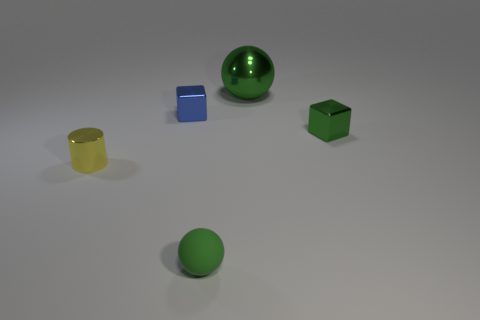Is there anything else that has the same size as the green metal sphere?
Provide a succinct answer. No. Is the number of tiny green rubber balls behind the blue cube less than the number of large objects?
Your answer should be compact. Yes. Do the large metal object and the tiny metal cylinder have the same color?
Offer a terse response. No. What size is the metallic object that is the same shape as the green matte object?
Offer a very short reply. Large. What number of other things are the same material as the blue object?
Ensure brevity in your answer.  3. Is the material of the small green thing that is behind the cylinder the same as the tiny green ball?
Make the answer very short. No. Are there the same number of things to the left of the tiny blue metallic object and tiny yellow shiny cylinders?
Offer a terse response. Yes. What is the size of the metallic sphere?
Make the answer very short. Large. There is another ball that is the same color as the metal ball; what is its material?
Give a very brief answer. Rubber. What number of tiny blocks are the same color as the rubber ball?
Provide a succinct answer. 1. 